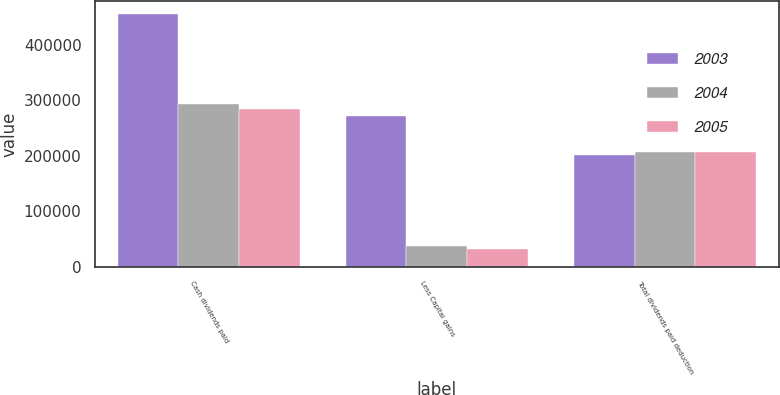<chart> <loc_0><loc_0><loc_500><loc_500><stacked_bar_chart><ecel><fcel>Cash dividends paid<fcel>Less Capital gains<fcel>Total dividends paid deduction<nl><fcel>2003<fcel>455606<fcel>270854<fcel>200960<nl><fcel>2004<fcel>292889<fcel>38655<fcel>207540<nl><fcel>2005<fcel>284868<fcel>32009<fcel>206222<nl></chart> 